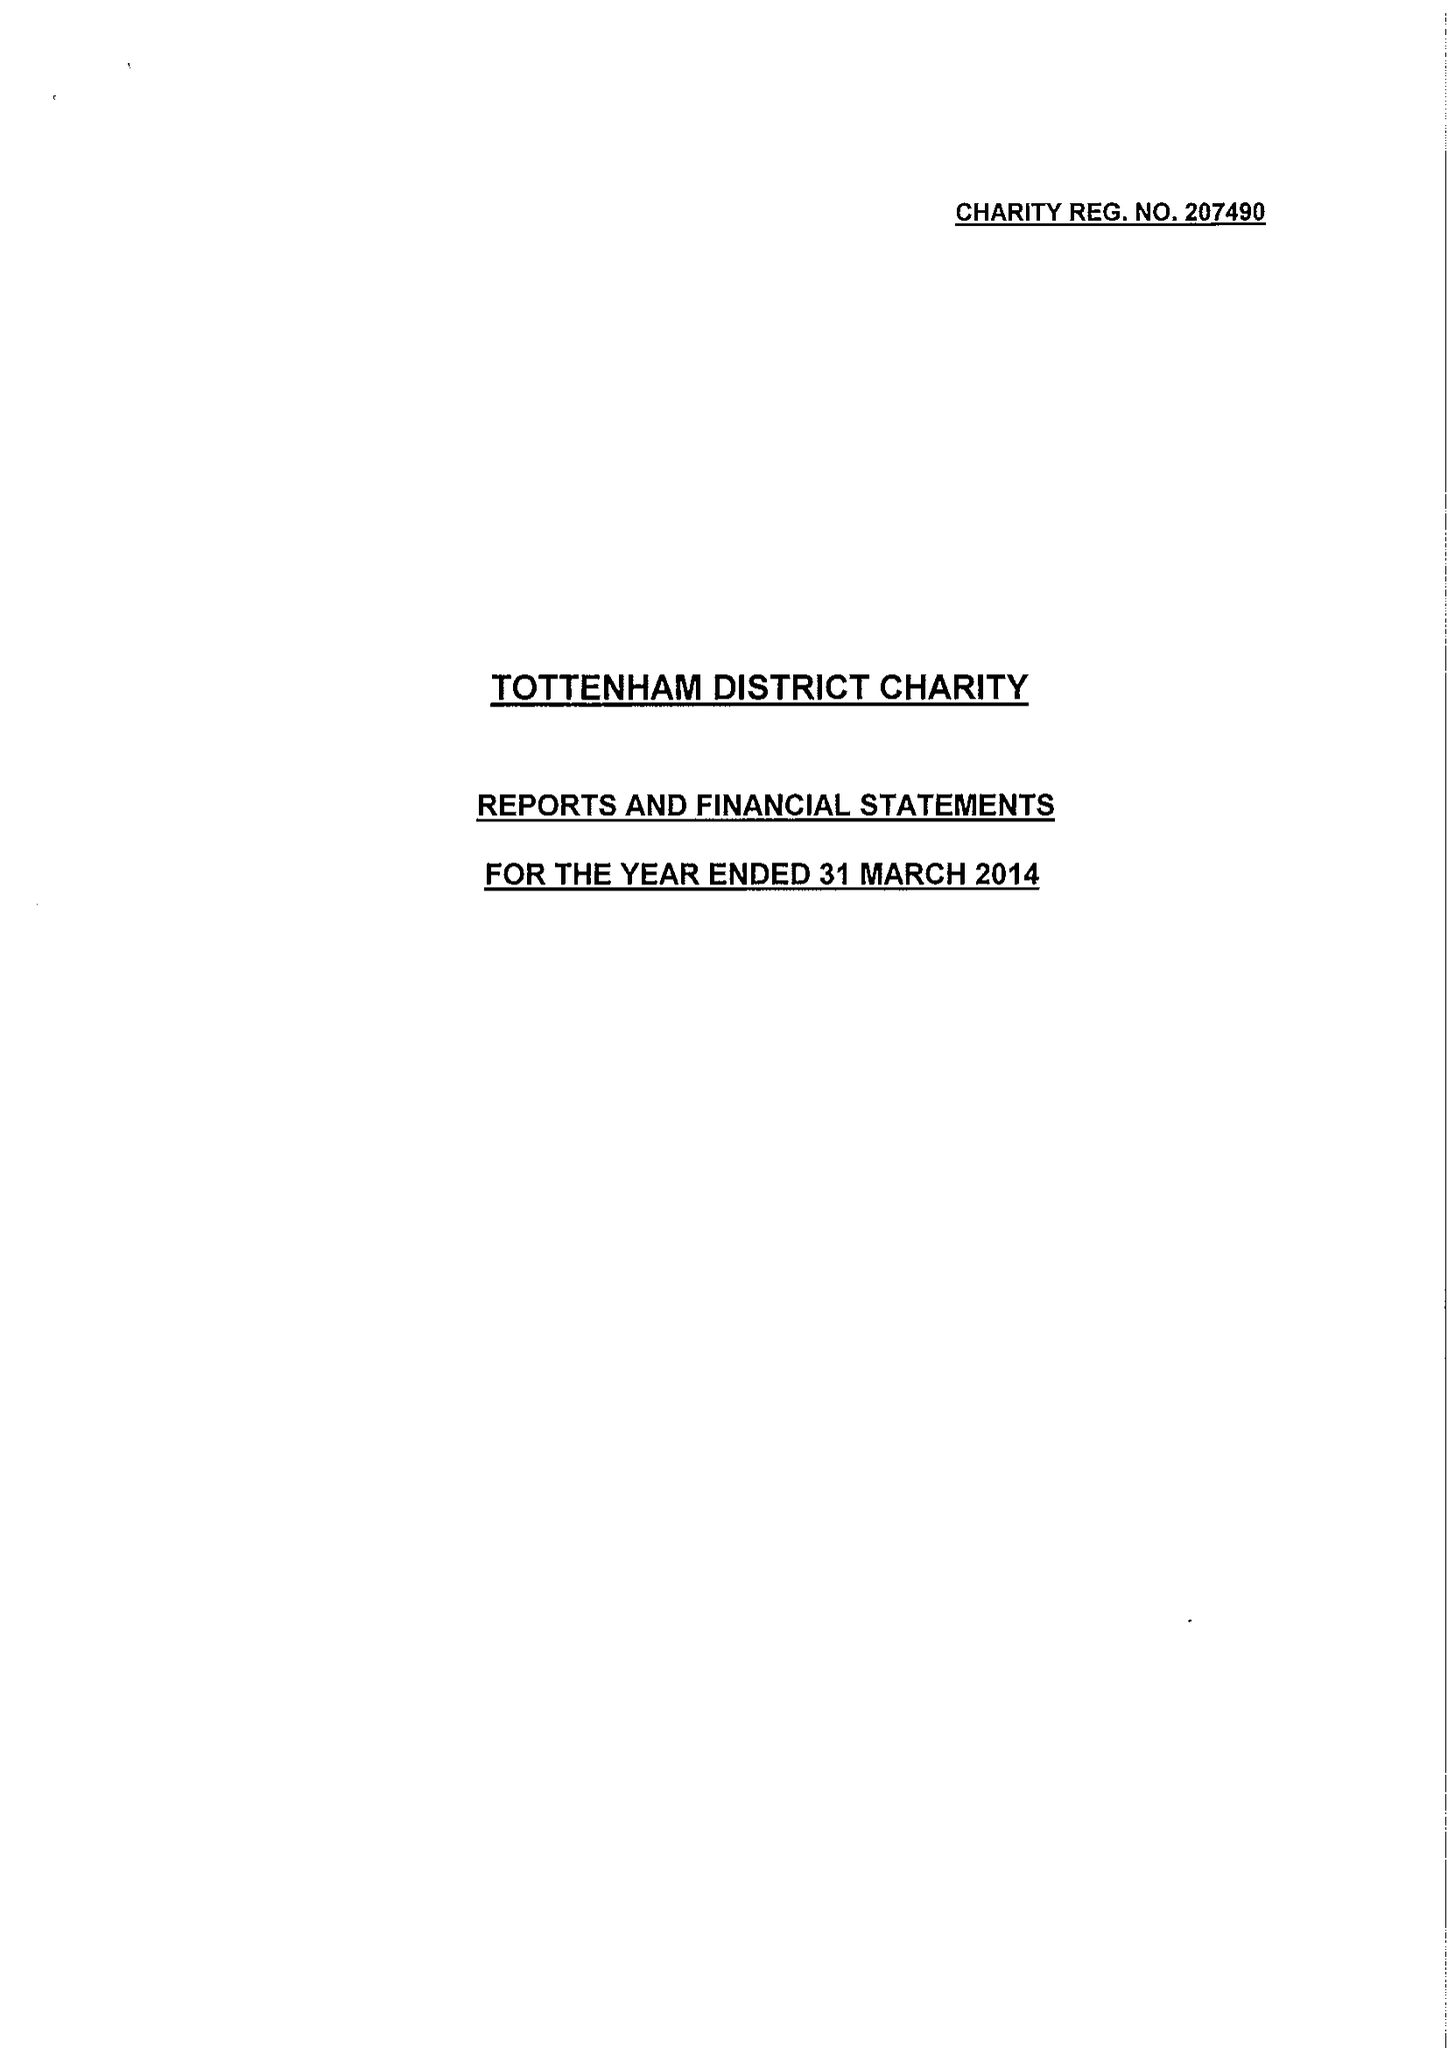What is the value for the report_date?
Answer the question using a single word or phrase. 2014-03-31 